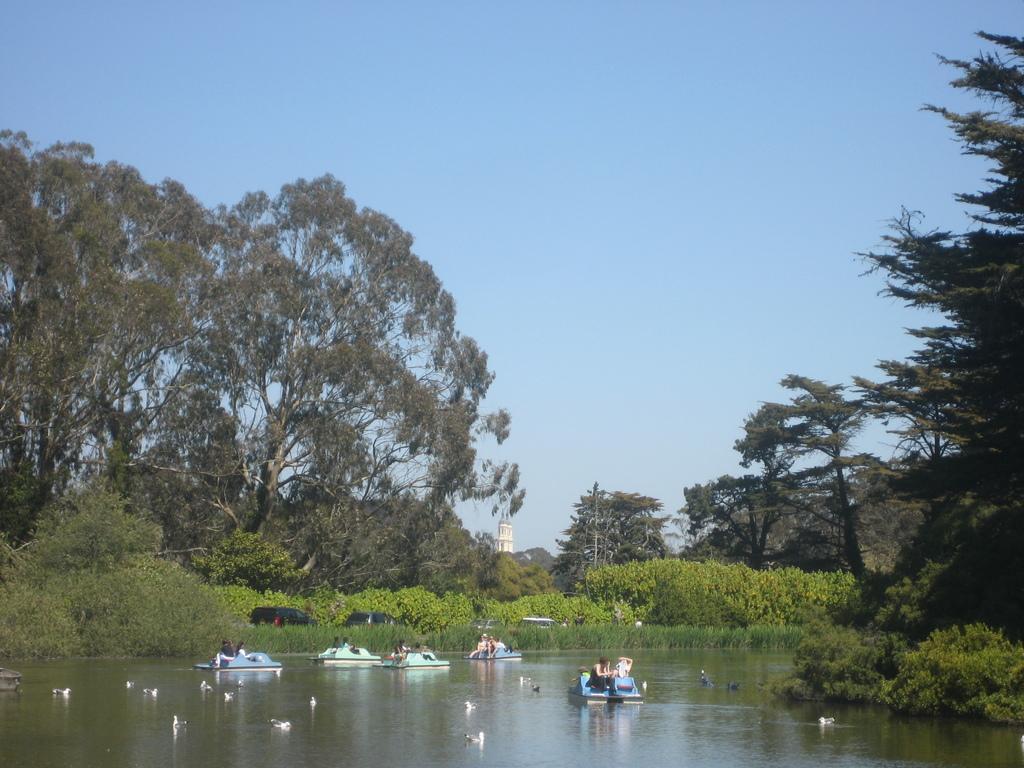Can you describe this image briefly? In this image we can see some people sailing the boats on the water. We can also see some birds. On the backside we can see some plants, trees, the tower and the sky which looks cloudy. 